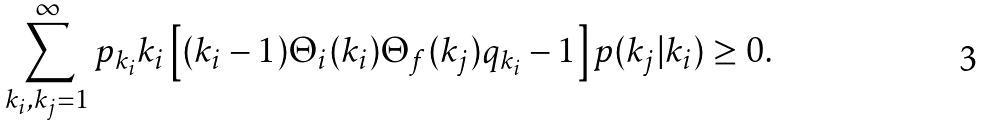Convert formula to latex. <formula><loc_0><loc_0><loc_500><loc_500>\sum _ { k _ { i } , k _ { j } = 1 } ^ { \infty } p _ { k _ { i } } k _ { i } \left [ ( k _ { i } - 1 ) \Theta _ { i } ( k _ { i } ) \Theta _ { f } ( k _ { j } ) q _ { k _ { i } } - 1 \right ] p ( k _ { j } | k _ { i } ) \geq 0 .</formula> 